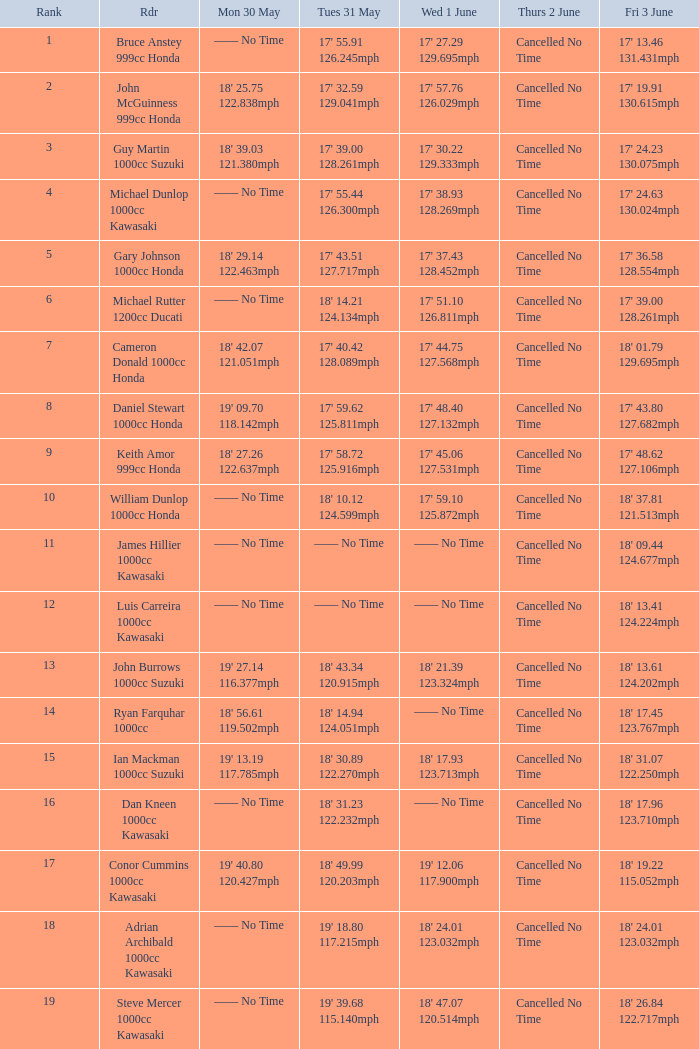What is the Thurs 2 June time for the rider with a Fri 3 June time of 17' 36.58 128.554mph? Cancelled No Time. 